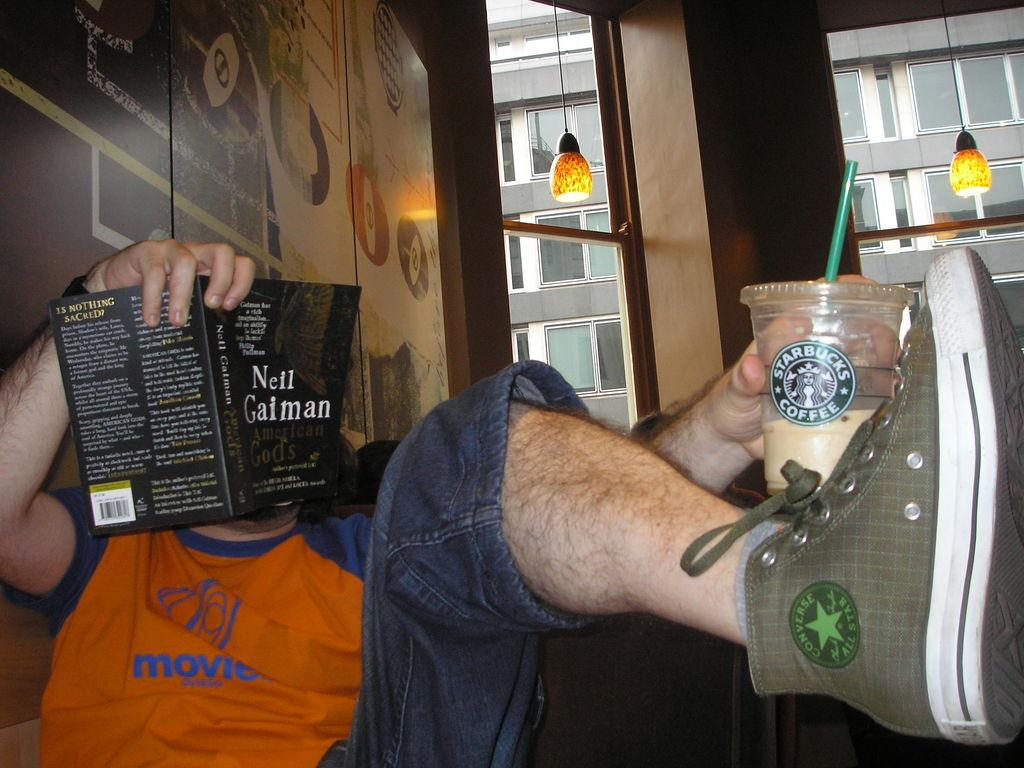Provide a one-sentence caption for the provided image. Man reading a book with his leg up while holding a Starbucks Coffee cup. 